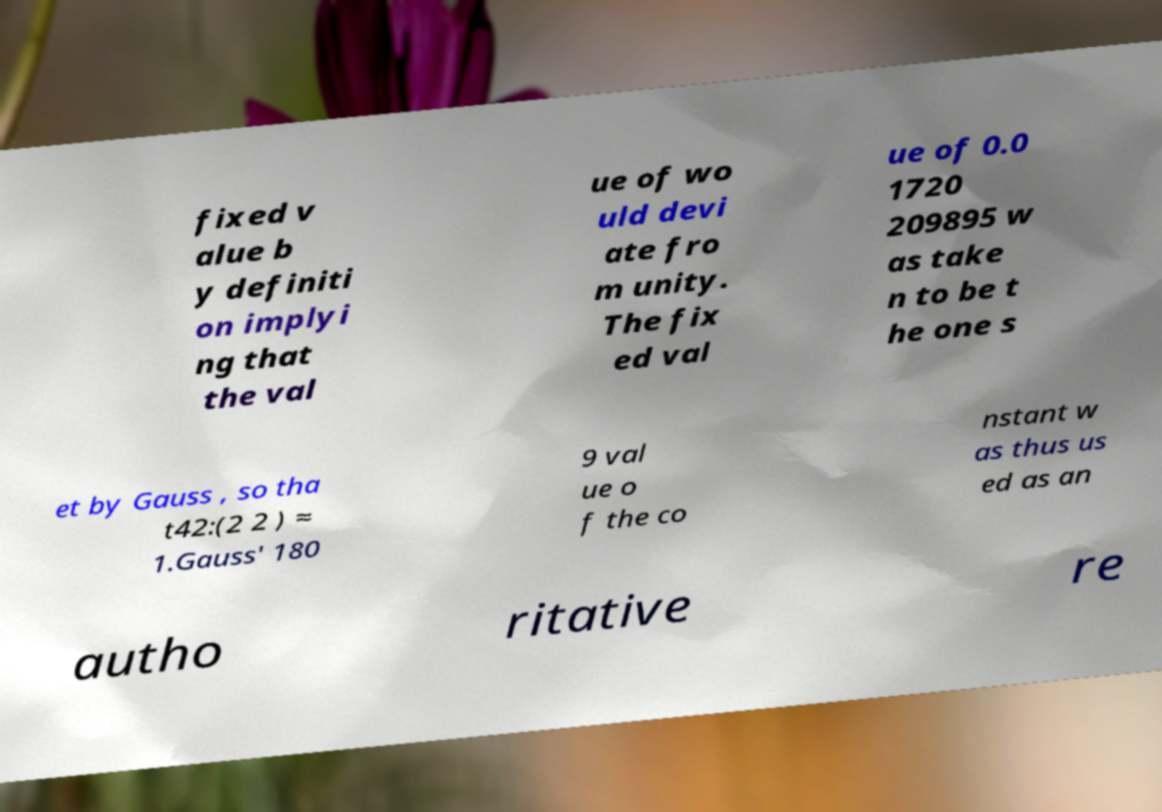For documentation purposes, I need the text within this image transcribed. Could you provide that? fixed v alue b y definiti on implyi ng that the val ue of wo uld devi ate fro m unity. The fix ed val ue of 0.0 1720 209895 w as take n to be t he one s et by Gauss , so tha t42:(2 2 ) ≈ 1.Gauss' 180 9 val ue o f the co nstant w as thus us ed as an autho ritative re 